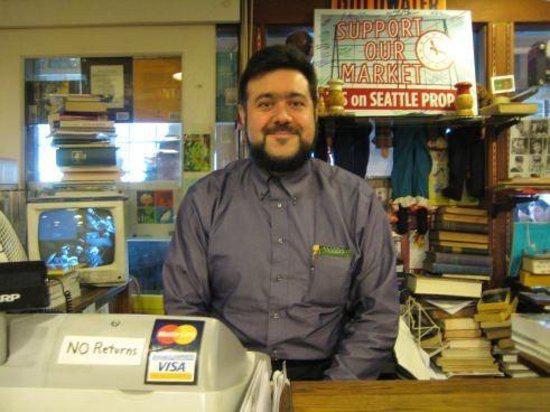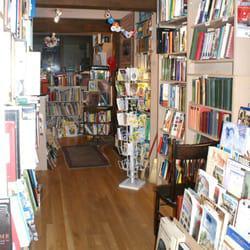The first image is the image on the left, the second image is the image on the right. Assess this claim about the two images: "There is at least one person sitting in front of a bookshelf with at least 10 books.". Correct or not? Answer yes or no. Yes. The first image is the image on the left, the second image is the image on the right. Examine the images to the left and right. Is the description "The man behind the counter has a beard." accurate? Answer yes or no. Yes. 